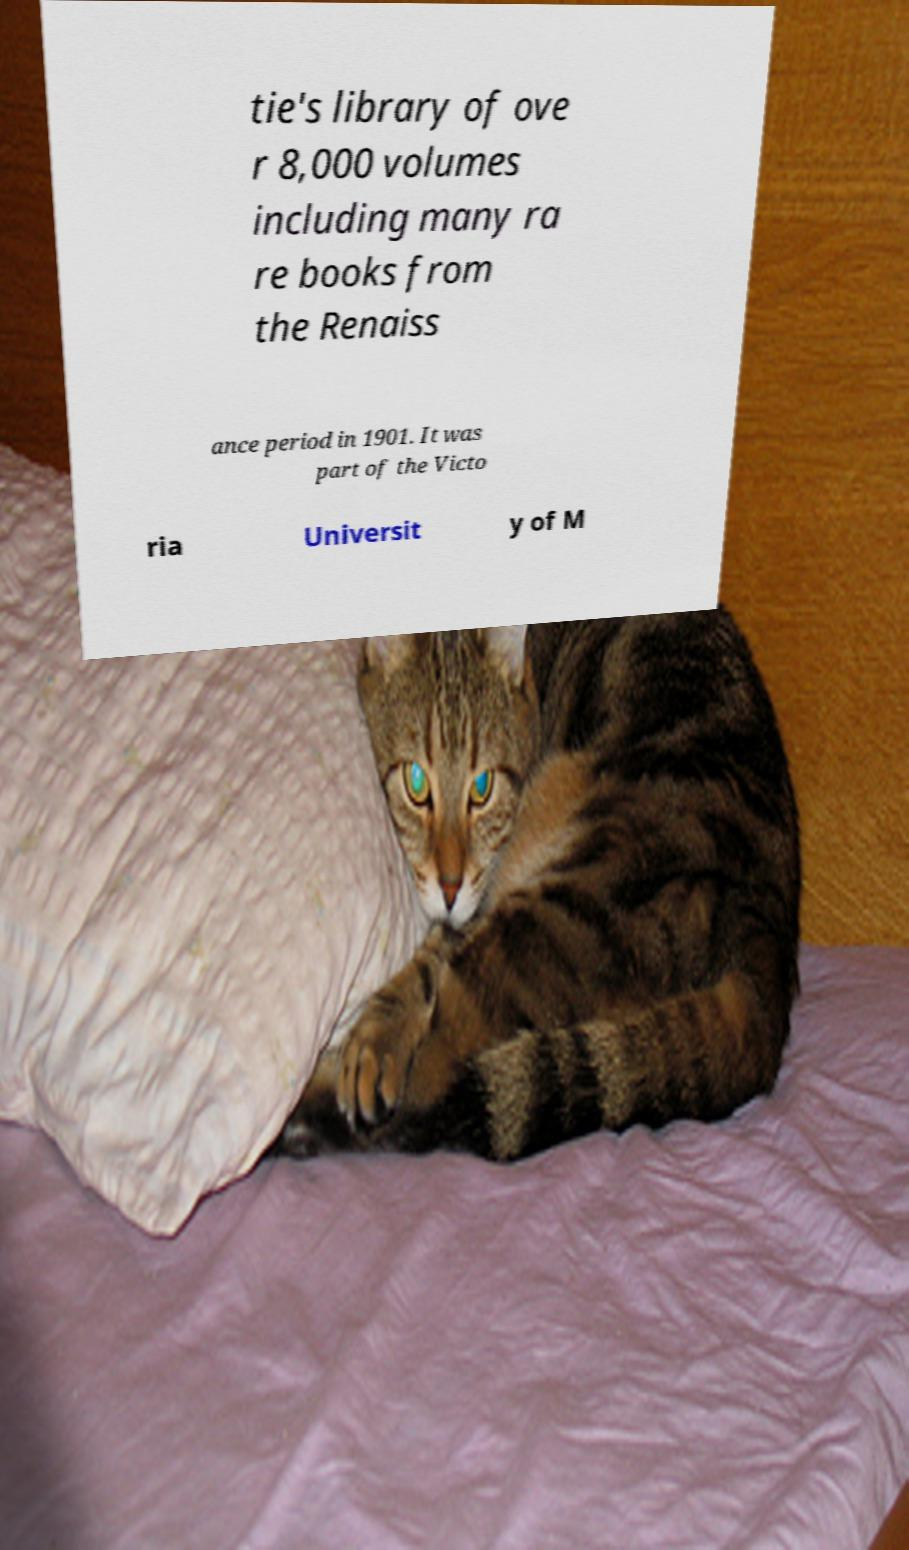For documentation purposes, I need the text within this image transcribed. Could you provide that? tie's library of ove r 8,000 volumes including many ra re books from the Renaiss ance period in 1901. It was part of the Victo ria Universit y of M 